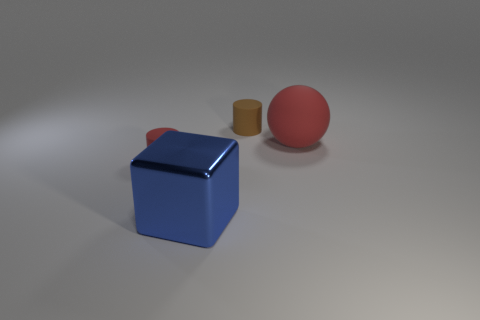Is there any other thing that has the same material as the cube?
Provide a succinct answer. No. There is a matte object that is both in front of the brown cylinder and left of the big red rubber ball; what is its color?
Keep it short and to the point. Red. Are the tiny thing that is behind the small red cylinder and the tiny cylinder on the left side of the cube made of the same material?
Ensure brevity in your answer.  Yes. Does the object on the left side of the blue block have the same size as the big blue thing?
Your response must be concise. No. Do the large ball and the small rubber thing that is right of the large shiny cube have the same color?
Provide a succinct answer. No. The other matte thing that is the same color as the large matte thing is what shape?
Give a very brief answer. Cylinder. The tiny red matte object is what shape?
Give a very brief answer. Cylinder. Do the big rubber thing and the big shiny object have the same color?
Provide a succinct answer. No. What number of things are matte objects that are behind the red cylinder or large brown rubber spheres?
Make the answer very short. 2. There is a red cylinder that is made of the same material as the red sphere; what is its size?
Keep it short and to the point. Small. 